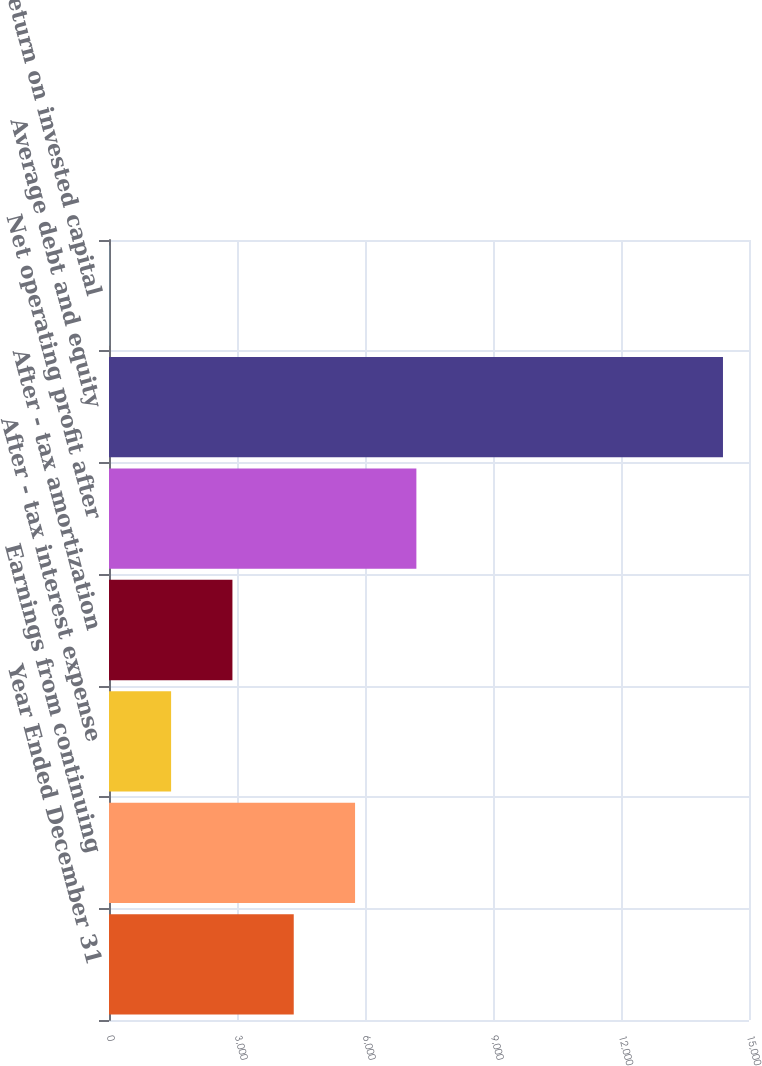Convert chart. <chart><loc_0><loc_0><loc_500><loc_500><bar_chart><fcel>Year Ended December 31<fcel>Earnings from continuing<fcel>After - tax interest expense<fcel>After - tax amortization<fcel>Net operating profit after<fcel>Average debt and equity<fcel>Return on invested capital<nl><fcel>4329.95<fcel>5767.1<fcel>1455.65<fcel>2892.8<fcel>7204.25<fcel>14390<fcel>18.5<nl></chart> 